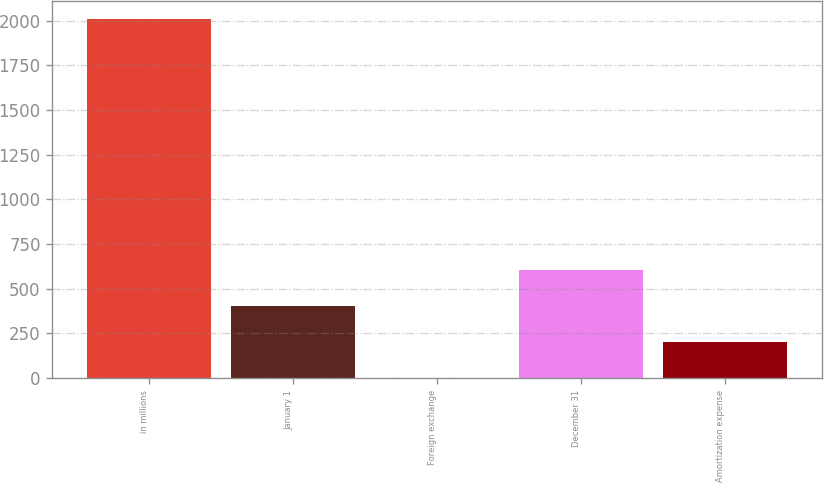Convert chart. <chart><loc_0><loc_0><loc_500><loc_500><bar_chart><fcel>in millions<fcel>January 1<fcel>Foreign exchange<fcel>December 31<fcel>Amortization expense<nl><fcel>2008<fcel>401.68<fcel>0.1<fcel>602.47<fcel>200.89<nl></chart> 